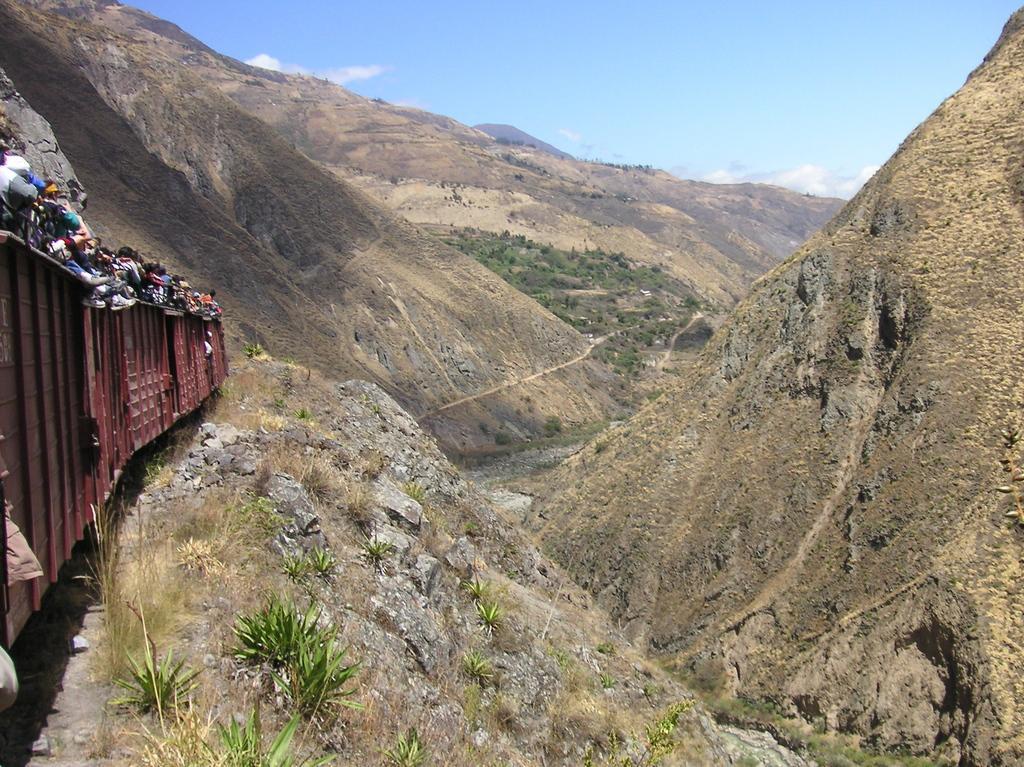Please provide a concise description of this image. As we can see in the image there are hills, grass, train, few people standing in train and there is a sky. 